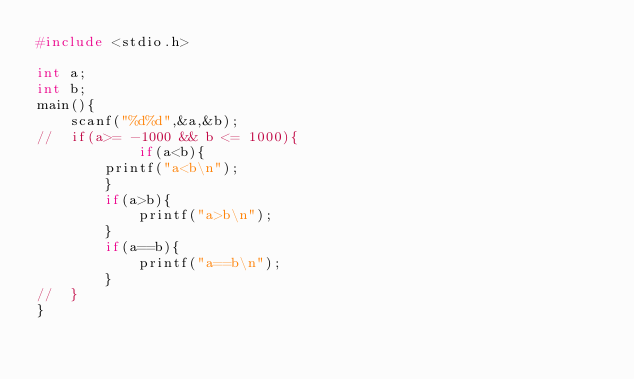<code> <loc_0><loc_0><loc_500><loc_500><_C_>#include <stdio.h>

int a;
int b;
main(){
	scanf("%d%d",&a,&b);
//	if(a>= -1000 && b <= 1000){
	        if(a<b){
		printf("a<b\n");
		}
		if(a>b){
			printf("a>b\n");
		}
		if(a==b){
			printf("a==b\n");
		}
//	}
}</code> 